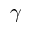Convert formula to latex. <formula><loc_0><loc_0><loc_500><loc_500>\gamma</formula> 